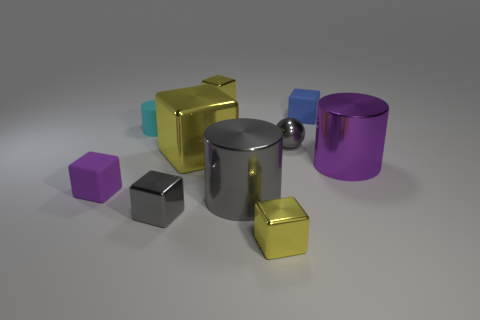What is the size of the cylinder that is the same color as the tiny ball?
Make the answer very short. Large. Are there any tiny gray cubes that have the same material as the big yellow thing?
Keep it short and to the point. Yes. There is a matte cube that is on the right side of the rubber thing in front of the gray object behind the purple matte block; what is its color?
Make the answer very short. Blue. How many purple things are large metal cylinders or tiny shiny balls?
Ensure brevity in your answer.  1. What number of small yellow objects are the same shape as the cyan rubber object?
Make the answer very short. 0. What is the shape of the cyan matte object that is the same size as the metal ball?
Your response must be concise. Cylinder. There is a small purple rubber thing; are there any big purple objects left of it?
Make the answer very short. No. There is a small gray shiny object to the left of the big yellow block; is there a tiny gray metal object that is in front of it?
Your answer should be very brief. No. Are there fewer purple matte cubes behind the cyan rubber thing than yellow shiny objects behind the large purple shiny cylinder?
Offer a very short reply. Yes. Are there any other things that are the same size as the gray cylinder?
Your answer should be compact. Yes. 